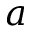Convert formula to latex. <formula><loc_0><loc_0><loc_500><loc_500>a</formula> 